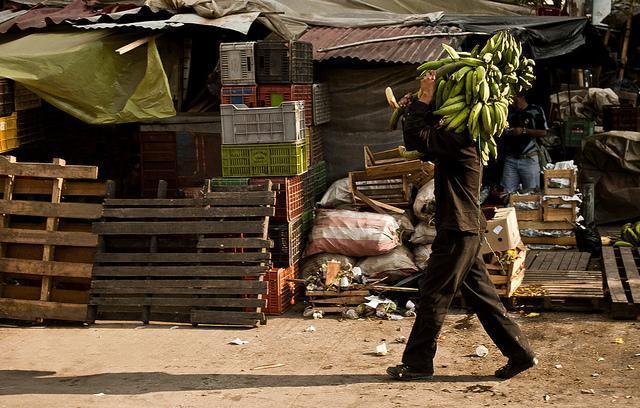How many bananas can you see?
Give a very brief answer. 2. How many people are in the picture?
Give a very brief answer. 2. 